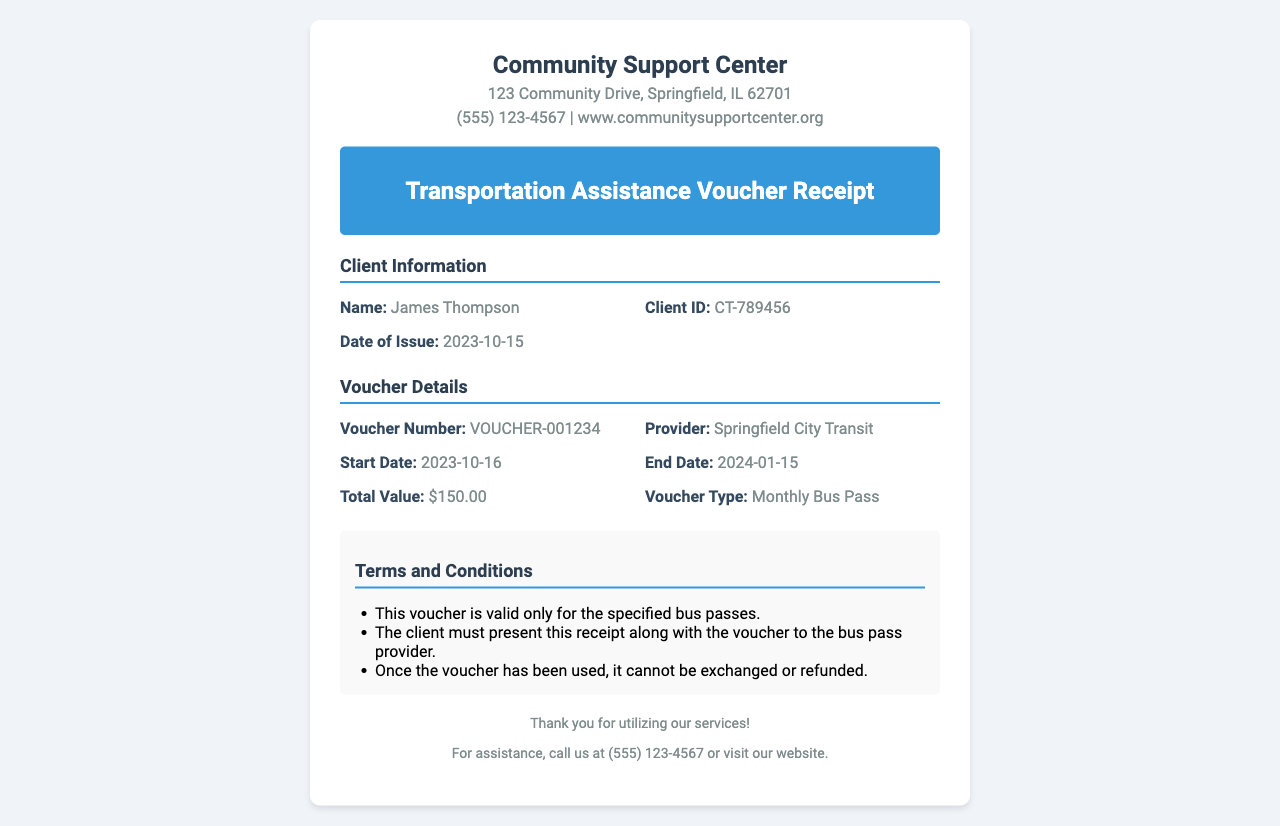What is the client's name? The client's name is listed in the Client Information section of the receipt.
Answer: James Thompson What is the Client ID? The Client ID is provided in the Client Information section and is specific to the client.
Answer: CT-789456 What is the date of issue? The date of issue is mentioned in the Client Information section of the receipt.
Answer: 2023-10-15 What is the voucher number? The voucher number is specified in the Voucher Details section of the receipt.
Answer: VOUCHER-001234 What is the total value of the voucher? The total value is clearly listed under the Voucher Details section as part of the financial information.
Answer: $150.00 What is the start date of the voucher? The start date is provided in the Voucher Details section and indicates when the voucher comes into effect.
Answer: 2023-10-16 How long is the validity period of the voucher? The validity period can be calculated from the start date and end date provided in the Voucher Details section.
Answer: 3 months Which provider is associated with the voucher? The provider's name is included in the Voucher Details section, indicating who the voucher is valid with.
Answer: Springfield City Transit What type of voucher is issued? The type of voucher is specified in the Voucher Details section, identifying the nature of the support offered.
Answer: Monthly Bus Pass 